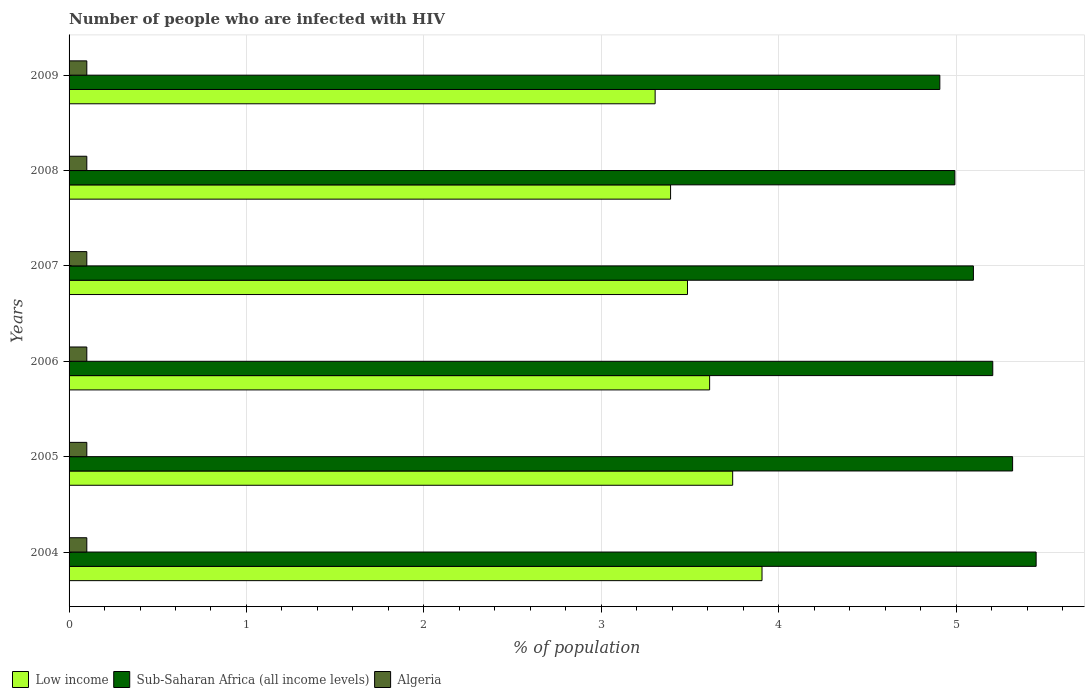Are the number of bars per tick equal to the number of legend labels?
Your response must be concise. Yes. In how many cases, is the number of bars for a given year not equal to the number of legend labels?
Ensure brevity in your answer.  0. What is the percentage of HIV infected population in in Sub-Saharan Africa (all income levels) in 2007?
Your answer should be compact. 5.1. Across all years, what is the maximum percentage of HIV infected population in in Algeria?
Keep it short and to the point. 0.1. Across all years, what is the minimum percentage of HIV infected population in in Sub-Saharan Africa (all income levels)?
Provide a succinct answer. 4.91. In which year was the percentage of HIV infected population in in Algeria maximum?
Offer a very short reply. 2004. In which year was the percentage of HIV infected population in in Algeria minimum?
Offer a terse response. 2004. What is the total percentage of HIV infected population in in Sub-Saharan Africa (all income levels) in the graph?
Offer a terse response. 30.98. What is the difference between the percentage of HIV infected population in in Algeria in 2005 and that in 2007?
Provide a short and direct response. 0. What is the difference between the percentage of HIV infected population in in Sub-Saharan Africa (all income levels) in 2004 and the percentage of HIV infected population in in Algeria in 2006?
Your response must be concise. 5.35. What is the average percentage of HIV infected population in in Sub-Saharan Africa (all income levels) per year?
Provide a short and direct response. 5.16. In the year 2007, what is the difference between the percentage of HIV infected population in in Sub-Saharan Africa (all income levels) and percentage of HIV infected population in in Algeria?
Provide a succinct answer. 5. What is the ratio of the percentage of HIV infected population in in Low income in 2005 to that in 2008?
Give a very brief answer. 1.1. Is the difference between the percentage of HIV infected population in in Sub-Saharan Africa (all income levels) in 2004 and 2009 greater than the difference between the percentage of HIV infected population in in Algeria in 2004 and 2009?
Your response must be concise. Yes. What is the difference between the highest and the second highest percentage of HIV infected population in in Algeria?
Keep it short and to the point. 0. What is the difference between the highest and the lowest percentage of HIV infected population in in Algeria?
Make the answer very short. 0. Is the sum of the percentage of HIV infected population in in Algeria in 2006 and 2008 greater than the maximum percentage of HIV infected population in in Low income across all years?
Ensure brevity in your answer.  No. What does the 3rd bar from the top in 2004 represents?
Make the answer very short. Low income. Is it the case that in every year, the sum of the percentage of HIV infected population in in Sub-Saharan Africa (all income levels) and percentage of HIV infected population in in Low income is greater than the percentage of HIV infected population in in Algeria?
Keep it short and to the point. Yes. Are the values on the major ticks of X-axis written in scientific E-notation?
Keep it short and to the point. No. Does the graph contain grids?
Provide a short and direct response. Yes. How many legend labels are there?
Provide a succinct answer. 3. What is the title of the graph?
Provide a short and direct response. Number of people who are infected with HIV. What is the label or title of the X-axis?
Offer a terse response. % of population. What is the label or title of the Y-axis?
Offer a terse response. Years. What is the % of population in Low income in 2004?
Offer a terse response. 3.91. What is the % of population of Sub-Saharan Africa (all income levels) in 2004?
Your answer should be very brief. 5.45. What is the % of population in Low income in 2005?
Ensure brevity in your answer.  3.74. What is the % of population of Sub-Saharan Africa (all income levels) in 2005?
Keep it short and to the point. 5.32. What is the % of population in Low income in 2006?
Offer a very short reply. 3.61. What is the % of population of Sub-Saharan Africa (all income levels) in 2006?
Your response must be concise. 5.21. What is the % of population in Algeria in 2006?
Make the answer very short. 0.1. What is the % of population in Low income in 2007?
Your response must be concise. 3.49. What is the % of population of Sub-Saharan Africa (all income levels) in 2007?
Provide a short and direct response. 5.1. What is the % of population in Algeria in 2007?
Give a very brief answer. 0.1. What is the % of population in Low income in 2008?
Ensure brevity in your answer.  3.39. What is the % of population in Sub-Saharan Africa (all income levels) in 2008?
Provide a short and direct response. 4.99. What is the % of population of Low income in 2009?
Keep it short and to the point. 3.3. What is the % of population of Sub-Saharan Africa (all income levels) in 2009?
Offer a terse response. 4.91. What is the % of population in Algeria in 2009?
Give a very brief answer. 0.1. Across all years, what is the maximum % of population in Low income?
Your answer should be compact. 3.91. Across all years, what is the maximum % of population in Sub-Saharan Africa (all income levels)?
Your answer should be very brief. 5.45. Across all years, what is the minimum % of population of Low income?
Keep it short and to the point. 3.3. Across all years, what is the minimum % of population of Sub-Saharan Africa (all income levels)?
Keep it short and to the point. 4.91. Across all years, what is the minimum % of population in Algeria?
Offer a terse response. 0.1. What is the total % of population of Low income in the graph?
Make the answer very short. 21.44. What is the total % of population in Sub-Saharan Africa (all income levels) in the graph?
Provide a short and direct response. 30.98. What is the difference between the % of population in Low income in 2004 and that in 2005?
Your answer should be very brief. 0.17. What is the difference between the % of population in Sub-Saharan Africa (all income levels) in 2004 and that in 2005?
Keep it short and to the point. 0.13. What is the difference between the % of population of Algeria in 2004 and that in 2005?
Offer a terse response. 0. What is the difference between the % of population of Low income in 2004 and that in 2006?
Ensure brevity in your answer.  0.3. What is the difference between the % of population in Sub-Saharan Africa (all income levels) in 2004 and that in 2006?
Give a very brief answer. 0.24. What is the difference between the % of population in Low income in 2004 and that in 2007?
Offer a terse response. 0.42. What is the difference between the % of population of Sub-Saharan Africa (all income levels) in 2004 and that in 2007?
Give a very brief answer. 0.35. What is the difference between the % of population in Algeria in 2004 and that in 2007?
Make the answer very short. 0. What is the difference between the % of population of Low income in 2004 and that in 2008?
Give a very brief answer. 0.52. What is the difference between the % of population in Sub-Saharan Africa (all income levels) in 2004 and that in 2008?
Provide a succinct answer. 0.46. What is the difference between the % of population in Low income in 2004 and that in 2009?
Ensure brevity in your answer.  0.6. What is the difference between the % of population of Sub-Saharan Africa (all income levels) in 2004 and that in 2009?
Offer a very short reply. 0.54. What is the difference between the % of population of Low income in 2005 and that in 2006?
Offer a very short reply. 0.13. What is the difference between the % of population in Sub-Saharan Africa (all income levels) in 2005 and that in 2006?
Provide a short and direct response. 0.11. What is the difference between the % of population in Algeria in 2005 and that in 2006?
Your response must be concise. 0. What is the difference between the % of population in Low income in 2005 and that in 2007?
Make the answer very short. 0.25. What is the difference between the % of population in Sub-Saharan Africa (all income levels) in 2005 and that in 2007?
Your answer should be compact. 0.22. What is the difference between the % of population in Algeria in 2005 and that in 2007?
Give a very brief answer. 0. What is the difference between the % of population of Sub-Saharan Africa (all income levels) in 2005 and that in 2008?
Your answer should be compact. 0.33. What is the difference between the % of population in Low income in 2005 and that in 2009?
Offer a very short reply. 0.44. What is the difference between the % of population in Sub-Saharan Africa (all income levels) in 2005 and that in 2009?
Provide a short and direct response. 0.41. What is the difference between the % of population in Low income in 2006 and that in 2007?
Your answer should be compact. 0.12. What is the difference between the % of population in Sub-Saharan Africa (all income levels) in 2006 and that in 2007?
Your answer should be very brief. 0.11. What is the difference between the % of population of Algeria in 2006 and that in 2007?
Offer a very short reply. 0. What is the difference between the % of population of Low income in 2006 and that in 2008?
Provide a succinct answer. 0.22. What is the difference between the % of population in Sub-Saharan Africa (all income levels) in 2006 and that in 2008?
Provide a succinct answer. 0.21. What is the difference between the % of population in Low income in 2006 and that in 2009?
Your response must be concise. 0.31. What is the difference between the % of population in Sub-Saharan Africa (all income levels) in 2006 and that in 2009?
Ensure brevity in your answer.  0.3. What is the difference between the % of population of Low income in 2007 and that in 2008?
Offer a very short reply. 0.1. What is the difference between the % of population of Sub-Saharan Africa (all income levels) in 2007 and that in 2008?
Ensure brevity in your answer.  0.1. What is the difference between the % of population of Low income in 2007 and that in 2009?
Your answer should be very brief. 0.18. What is the difference between the % of population in Sub-Saharan Africa (all income levels) in 2007 and that in 2009?
Make the answer very short. 0.19. What is the difference between the % of population in Algeria in 2007 and that in 2009?
Make the answer very short. 0. What is the difference between the % of population in Low income in 2008 and that in 2009?
Your answer should be very brief. 0.09. What is the difference between the % of population of Sub-Saharan Africa (all income levels) in 2008 and that in 2009?
Make the answer very short. 0.08. What is the difference between the % of population in Low income in 2004 and the % of population in Sub-Saharan Africa (all income levels) in 2005?
Your answer should be compact. -1.41. What is the difference between the % of population of Low income in 2004 and the % of population of Algeria in 2005?
Offer a terse response. 3.81. What is the difference between the % of population in Sub-Saharan Africa (all income levels) in 2004 and the % of population in Algeria in 2005?
Give a very brief answer. 5.35. What is the difference between the % of population in Low income in 2004 and the % of population in Sub-Saharan Africa (all income levels) in 2006?
Make the answer very short. -1.3. What is the difference between the % of population of Low income in 2004 and the % of population of Algeria in 2006?
Offer a terse response. 3.81. What is the difference between the % of population in Sub-Saharan Africa (all income levels) in 2004 and the % of population in Algeria in 2006?
Offer a very short reply. 5.35. What is the difference between the % of population in Low income in 2004 and the % of population in Sub-Saharan Africa (all income levels) in 2007?
Make the answer very short. -1.19. What is the difference between the % of population of Low income in 2004 and the % of population of Algeria in 2007?
Ensure brevity in your answer.  3.81. What is the difference between the % of population in Sub-Saharan Africa (all income levels) in 2004 and the % of population in Algeria in 2007?
Keep it short and to the point. 5.35. What is the difference between the % of population in Low income in 2004 and the % of population in Sub-Saharan Africa (all income levels) in 2008?
Ensure brevity in your answer.  -1.09. What is the difference between the % of population of Low income in 2004 and the % of population of Algeria in 2008?
Your answer should be very brief. 3.81. What is the difference between the % of population in Sub-Saharan Africa (all income levels) in 2004 and the % of population in Algeria in 2008?
Keep it short and to the point. 5.35. What is the difference between the % of population in Low income in 2004 and the % of population in Sub-Saharan Africa (all income levels) in 2009?
Offer a very short reply. -1. What is the difference between the % of population in Low income in 2004 and the % of population in Algeria in 2009?
Make the answer very short. 3.81. What is the difference between the % of population of Sub-Saharan Africa (all income levels) in 2004 and the % of population of Algeria in 2009?
Offer a very short reply. 5.35. What is the difference between the % of population of Low income in 2005 and the % of population of Sub-Saharan Africa (all income levels) in 2006?
Your answer should be very brief. -1.47. What is the difference between the % of population in Low income in 2005 and the % of population in Algeria in 2006?
Offer a terse response. 3.64. What is the difference between the % of population in Sub-Saharan Africa (all income levels) in 2005 and the % of population in Algeria in 2006?
Offer a very short reply. 5.22. What is the difference between the % of population of Low income in 2005 and the % of population of Sub-Saharan Africa (all income levels) in 2007?
Ensure brevity in your answer.  -1.36. What is the difference between the % of population of Low income in 2005 and the % of population of Algeria in 2007?
Your answer should be very brief. 3.64. What is the difference between the % of population in Sub-Saharan Africa (all income levels) in 2005 and the % of population in Algeria in 2007?
Your answer should be compact. 5.22. What is the difference between the % of population in Low income in 2005 and the % of population in Sub-Saharan Africa (all income levels) in 2008?
Offer a terse response. -1.25. What is the difference between the % of population in Low income in 2005 and the % of population in Algeria in 2008?
Your response must be concise. 3.64. What is the difference between the % of population of Sub-Saharan Africa (all income levels) in 2005 and the % of population of Algeria in 2008?
Ensure brevity in your answer.  5.22. What is the difference between the % of population of Low income in 2005 and the % of population of Sub-Saharan Africa (all income levels) in 2009?
Your answer should be compact. -1.17. What is the difference between the % of population of Low income in 2005 and the % of population of Algeria in 2009?
Give a very brief answer. 3.64. What is the difference between the % of population in Sub-Saharan Africa (all income levels) in 2005 and the % of population in Algeria in 2009?
Your answer should be compact. 5.22. What is the difference between the % of population in Low income in 2006 and the % of population in Sub-Saharan Africa (all income levels) in 2007?
Offer a terse response. -1.49. What is the difference between the % of population of Low income in 2006 and the % of population of Algeria in 2007?
Keep it short and to the point. 3.51. What is the difference between the % of population in Sub-Saharan Africa (all income levels) in 2006 and the % of population in Algeria in 2007?
Your answer should be very brief. 5.11. What is the difference between the % of population in Low income in 2006 and the % of population in Sub-Saharan Africa (all income levels) in 2008?
Offer a very short reply. -1.38. What is the difference between the % of population in Low income in 2006 and the % of population in Algeria in 2008?
Keep it short and to the point. 3.51. What is the difference between the % of population in Sub-Saharan Africa (all income levels) in 2006 and the % of population in Algeria in 2008?
Your response must be concise. 5.11. What is the difference between the % of population in Low income in 2006 and the % of population in Sub-Saharan Africa (all income levels) in 2009?
Give a very brief answer. -1.3. What is the difference between the % of population of Low income in 2006 and the % of population of Algeria in 2009?
Make the answer very short. 3.51. What is the difference between the % of population of Sub-Saharan Africa (all income levels) in 2006 and the % of population of Algeria in 2009?
Keep it short and to the point. 5.11. What is the difference between the % of population of Low income in 2007 and the % of population of Sub-Saharan Africa (all income levels) in 2008?
Your answer should be compact. -1.51. What is the difference between the % of population of Low income in 2007 and the % of population of Algeria in 2008?
Give a very brief answer. 3.39. What is the difference between the % of population in Sub-Saharan Africa (all income levels) in 2007 and the % of population in Algeria in 2008?
Provide a short and direct response. 5. What is the difference between the % of population in Low income in 2007 and the % of population in Sub-Saharan Africa (all income levels) in 2009?
Your response must be concise. -1.42. What is the difference between the % of population in Low income in 2007 and the % of population in Algeria in 2009?
Keep it short and to the point. 3.39. What is the difference between the % of population in Sub-Saharan Africa (all income levels) in 2007 and the % of population in Algeria in 2009?
Your answer should be compact. 5. What is the difference between the % of population of Low income in 2008 and the % of population of Sub-Saharan Africa (all income levels) in 2009?
Keep it short and to the point. -1.52. What is the difference between the % of population in Low income in 2008 and the % of population in Algeria in 2009?
Your answer should be compact. 3.29. What is the difference between the % of population in Sub-Saharan Africa (all income levels) in 2008 and the % of population in Algeria in 2009?
Your answer should be compact. 4.89. What is the average % of population of Low income per year?
Your answer should be compact. 3.57. What is the average % of population of Sub-Saharan Africa (all income levels) per year?
Offer a very short reply. 5.16. In the year 2004, what is the difference between the % of population of Low income and % of population of Sub-Saharan Africa (all income levels)?
Offer a terse response. -1.55. In the year 2004, what is the difference between the % of population of Low income and % of population of Algeria?
Provide a short and direct response. 3.81. In the year 2004, what is the difference between the % of population of Sub-Saharan Africa (all income levels) and % of population of Algeria?
Give a very brief answer. 5.35. In the year 2005, what is the difference between the % of population of Low income and % of population of Sub-Saharan Africa (all income levels)?
Give a very brief answer. -1.58. In the year 2005, what is the difference between the % of population of Low income and % of population of Algeria?
Keep it short and to the point. 3.64. In the year 2005, what is the difference between the % of population in Sub-Saharan Africa (all income levels) and % of population in Algeria?
Ensure brevity in your answer.  5.22. In the year 2006, what is the difference between the % of population in Low income and % of population in Sub-Saharan Africa (all income levels)?
Give a very brief answer. -1.6. In the year 2006, what is the difference between the % of population in Low income and % of population in Algeria?
Provide a short and direct response. 3.51. In the year 2006, what is the difference between the % of population in Sub-Saharan Africa (all income levels) and % of population in Algeria?
Keep it short and to the point. 5.11. In the year 2007, what is the difference between the % of population in Low income and % of population in Sub-Saharan Africa (all income levels)?
Offer a terse response. -1.61. In the year 2007, what is the difference between the % of population of Low income and % of population of Algeria?
Keep it short and to the point. 3.39. In the year 2007, what is the difference between the % of population in Sub-Saharan Africa (all income levels) and % of population in Algeria?
Offer a very short reply. 5. In the year 2008, what is the difference between the % of population of Low income and % of population of Sub-Saharan Africa (all income levels)?
Give a very brief answer. -1.6. In the year 2008, what is the difference between the % of population of Low income and % of population of Algeria?
Offer a terse response. 3.29. In the year 2008, what is the difference between the % of population of Sub-Saharan Africa (all income levels) and % of population of Algeria?
Offer a very short reply. 4.89. In the year 2009, what is the difference between the % of population in Low income and % of population in Sub-Saharan Africa (all income levels)?
Give a very brief answer. -1.6. In the year 2009, what is the difference between the % of population in Low income and % of population in Algeria?
Give a very brief answer. 3.2. In the year 2009, what is the difference between the % of population in Sub-Saharan Africa (all income levels) and % of population in Algeria?
Ensure brevity in your answer.  4.81. What is the ratio of the % of population in Low income in 2004 to that in 2005?
Provide a short and direct response. 1.04. What is the ratio of the % of population of Sub-Saharan Africa (all income levels) in 2004 to that in 2005?
Offer a very short reply. 1.02. What is the ratio of the % of population of Low income in 2004 to that in 2006?
Your response must be concise. 1.08. What is the ratio of the % of population in Sub-Saharan Africa (all income levels) in 2004 to that in 2006?
Your answer should be very brief. 1.05. What is the ratio of the % of population in Algeria in 2004 to that in 2006?
Your answer should be very brief. 1. What is the ratio of the % of population in Low income in 2004 to that in 2007?
Give a very brief answer. 1.12. What is the ratio of the % of population of Sub-Saharan Africa (all income levels) in 2004 to that in 2007?
Keep it short and to the point. 1.07. What is the ratio of the % of population in Low income in 2004 to that in 2008?
Keep it short and to the point. 1.15. What is the ratio of the % of population in Sub-Saharan Africa (all income levels) in 2004 to that in 2008?
Ensure brevity in your answer.  1.09. What is the ratio of the % of population in Low income in 2004 to that in 2009?
Make the answer very short. 1.18. What is the ratio of the % of population in Sub-Saharan Africa (all income levels) in 2004 to that in 2009?
Provide a succinct answer. 1.11. What is the ratio of the % of population of Low income in 2005 to that in 2006?
Give a very brief answer. 1.04. What is the ratio of the % of population in Sub-Saharan Africa (all income levels) in 2005 to that in 2006?
Offer a very short reply. 1.02. What is the ratio of the % of population in Low income in 2005 to that in 2007?
Your response must be concise. 1.07. What is the ratio of the % of population in Sub-Saharan Africa (all income levels) in 2005 to that in 2007?
Offer a very short reply. 1.04. What is the ratio of the % of population in Low income in 2005 to that in 2008?
Provide a short and direct response. 1.1. What is the ratio of the % of population of Sub-Saharan Africa (all income levels) in 2005 to that in 2008?
Make the answer very short. 1.07. What is the ratio of the % of population of Algeria in 2005 to that in 2008?
Keep it short and to the point. 1. What is the ratio of the % of population of Low income in 2005 to that in 2009?
Offer a very short reply. 1.13. What is the ratio of the % of population of Sub-Saharan Africa (all income levels) in 2005 to that in 2009?
Your answer should be very brief. 1.08. What is the ratio of the % of population of Low income in 2006 to that in 2007?
Offer a terse response. 1.04. What is the ratio of the % of population of Sub-Saharan Africa (all income levels) in 2006 to that in 2007?
Offer a terse response. 1.02. What is the ratio of the % of population in Algeria in 2006 to that in 2007?
Your answer should be very brief. 1. What is the ratio of the % of population in Low income in 2006 to that in 2008?
Give a very brief answer. 1.06. What is the ratio of the % of population in Sub-Saharan Africa (all income levels) in 2006 to that in 2008?
Your answer should be compact. 1.04. What is the ratio of the % of population of Algeria in 2006 to that in 2008?
Provide a short and direct response. 1. What is the ratio of the % of population in Low income in 2006 to that in 2009?
Keep it short and to the point. 1.09. What is the ratio of the % of population in Sub-Saharan Africa (all income levels) in 2006 to that in 2009?
Make the answer very short. 1.06. What is the ratio of the % of population in Algeria in 2006 to that in 2009?
Your answer should be compact. 1. What is the ratio of the % of population in Low income in 2007 to that in 2008?
Your answer should be very brief. 1.03. What is the ratio of the % of population in Sub-Saharan Africa (all income levels) in 2007 to that in 2008?
Provide a succinct answer. 1.02. What is the ratio of the % of population of Algeria in 2007 to that in 2008?
Give a very brief answer. 1. What is the ratio of the % of population in Low income in 2007 to that in 2009?
Provide a succinct answer. 1.06. What is the ratio of the % of population in Sub-Saharan Africa (all income levels) in 2007 to that in 2009?
Your response must be concise. 1.04. What is the ratio of the % of population in Algeria in 2007 to that in 2009?
Provide a short and direct response. 1. What is the ratio of the % of population in Low income in 2008 to that in 2009?
Your response must be concise. 1.03. What is the ratio of the % of population in Sub-Saharan Africa (all income levels) in 2008 to that in 2009?
Keep it short and to the point. 1.02. What is the ratio of the % of population in Algeria in 2008 to that in 2009?
Provide a short and direct response. 1. What is the difference between the highest and the second highest % of population of Low income?
Your answer should be very brief. 0.17. What is the difference between the highest and the second highest % of population of Sub-Saharan Africa (all income levels)?
Your response must be concise. 0.13. What is the difference between the highest and the second highest % of population in Algeria?
Provide a succinct answer. 0. What is the difference between the highest and the lowest % of population in Low income?
Provide a short and direct response. 0.6. What is the difference between the highest and the lowest % of population in Sub-Saharan Africa (all income levels)?
Your response must be concise. 0.54. What is the difference between the highest and the lowest % of population of Algeria?
Offer a very short reply. 0. 